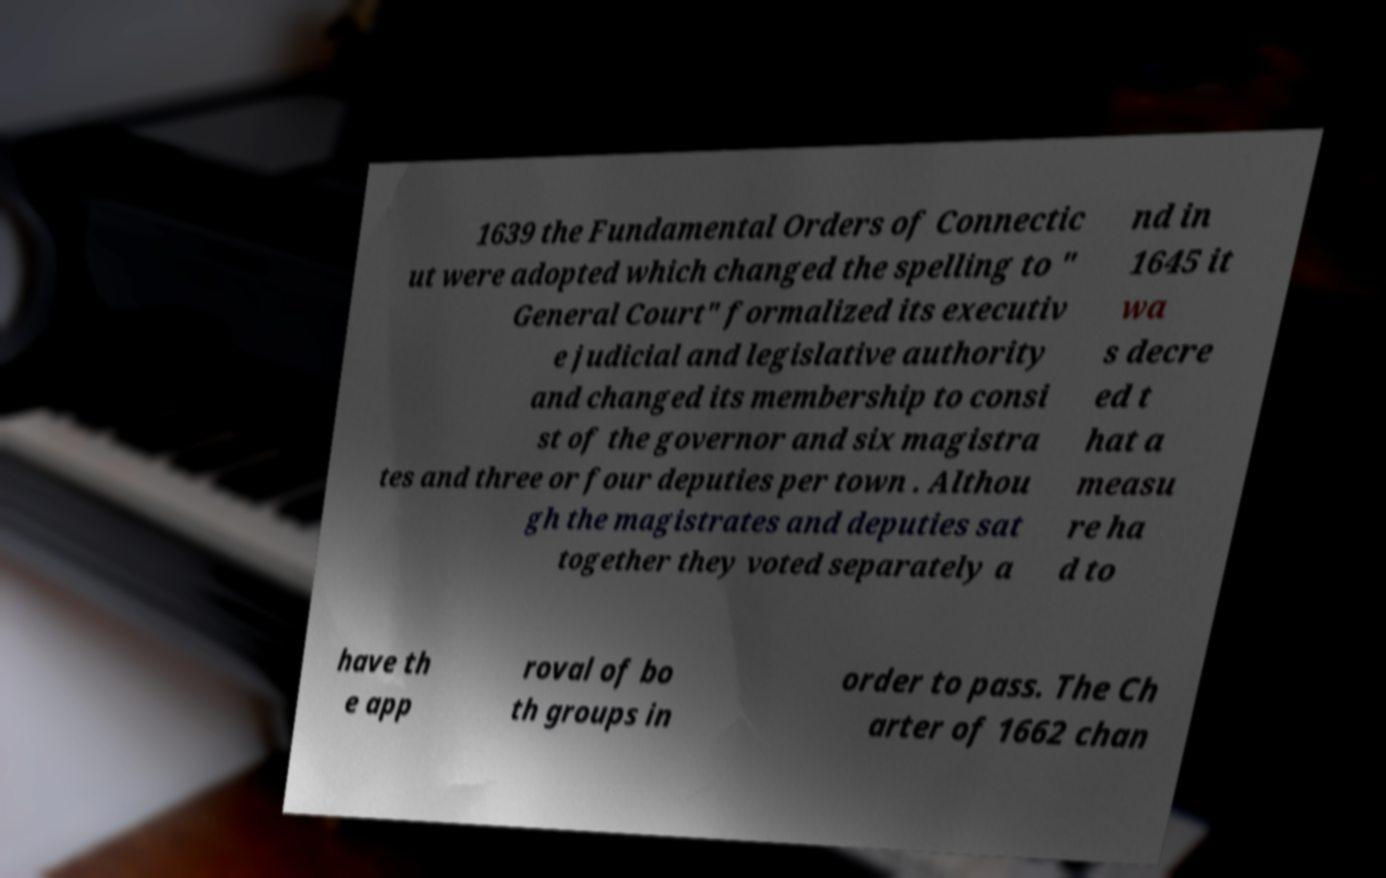For documentation purposes, I need the text within this image transcribed. Could you provide that? 1639 the Fundamental Orders of Connectic ut were adopted which changed the spelling to " General Court" formalized its executiv e judicial and legislative authority and changed its membership to consi st of the governor and six magistra tes and three or four deputies per town . Althou gh the magistrates and deputies sat together they voted separately a nd in 1645 it wa s decre ed t hat a measu re ha d to have th e app roval of bo th groups in order to pass. The Ch arter of 1662 chan 